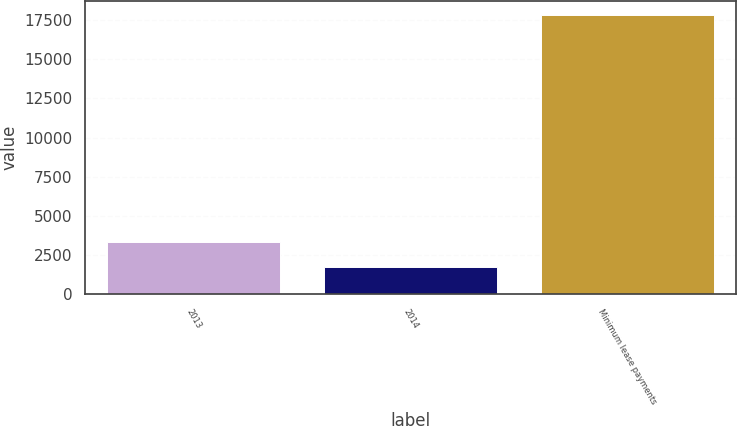Convert chart to OTSL. <chart><loc_0><loc_0><loc_500><loc_500><bar_chart><fcel>2013<fcel>2014<fcel>Minimum lease payments<nl><fcel>3369.8<fcel>1763<fcel>17831<nl></chart> 